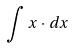Convert formula to latex. <formula><loc_0><loc_0><loc_500><loc_500>\int x \cdot d x</formula> 